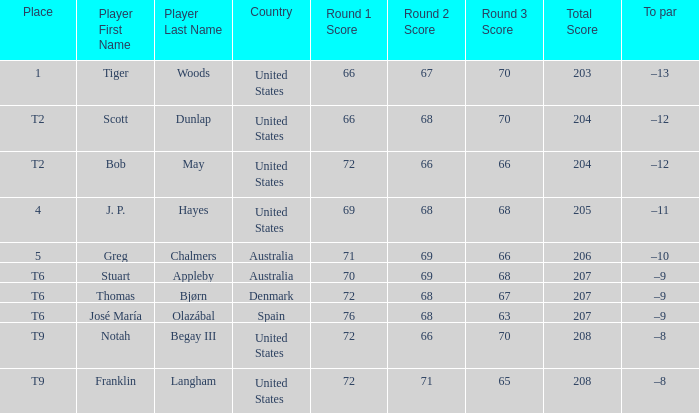What country does athlete thomas bjørn belong to? Denmark. 